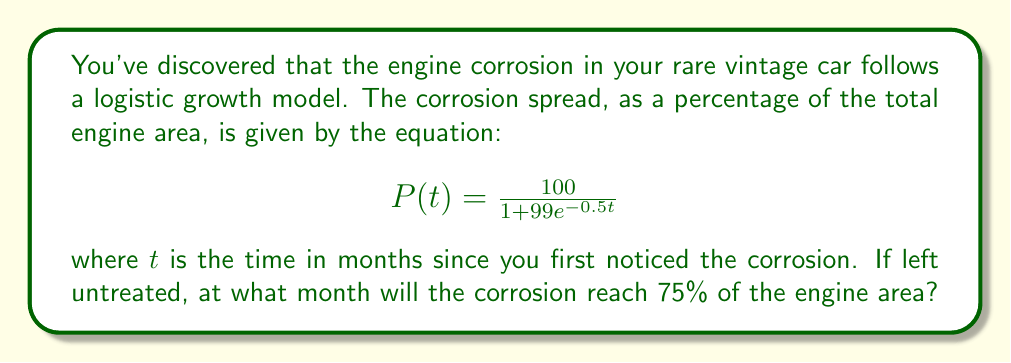Show me your answer to this math problem. To solve this problem, we need to use the logistic growth equation and determine when P(t) = 75%. Let's approach this step-by-step:

1) We start with the given logistic growth equation:

   $$P(t) = \frac{100}{1 + 99e^{-0.5t}}$$

2) We want to find t when P(t) = 75, so we set up the equation:

   $$75 = \frac{100}{1 + 99e^{-0.5t}}$$

3) Multiply both sides by $(1 + 99e^{-0.5t})$:

   $$75(1 + 99e^{-0.5t}) = 100$$

4) Distribute on the left side:

   $$75 + 7425e^{-0.5t} = 100$$

5) Subtract 75 from both sides:

   $$7425e^{-0.5t} = 25$$

6) Divide both sides by 7425:

   $$e^{-0.5t} = \frac{1}{297}$$

7) Take the natural log of both sides:

   $$-0.5t = \ln(\frac{1}{297})$$

8) Multiply both sides by -2:

   $$t = -2\ln(\frac{1}{297}) = 2\ln(297)$$

9) Calculate the final value:

   $$t \approx 11.44$$

Since we're dealing with months, we round up to the nearest whole number.
Answer: The corrosion will reach 75% of the engine area after approximately 12 months if left untreated. 